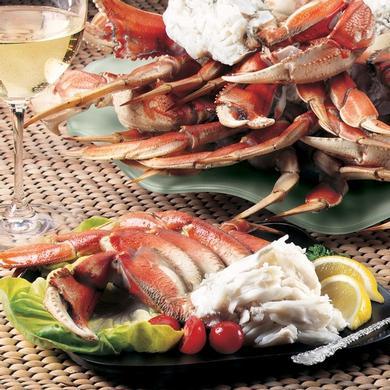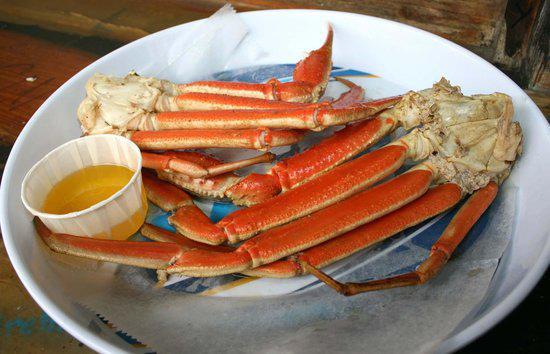The first image is the image on the left, the second image is the image on the right. Analyze the images presented: Is the assertion "One image shows long red crab legs connected by whitish meat served on a round white plate." valid? Answer yes or no. Yes. The first image is the image on the left, the second image is the image on the right. Given the left and right images, does the statement "there are two snow crab clusters on a white round plate" hold true? Answer yes or no. Yes. 